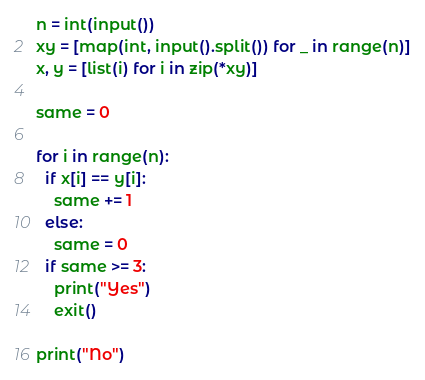<code> <loc_0><loc_0><loc_500><loc_500><_Python_>n = int(input())
xy = [map(int, input().split()) for _ in range(n)]
x, y = [list(i) for i in zip(*xy)]

same = 0

for i in range(n):
  if x[i] == y[i]:
    same += 1
  else:
    same = 0
  if same >= 3:
    print("Yes")
    exit()
    
print("No")</code> 